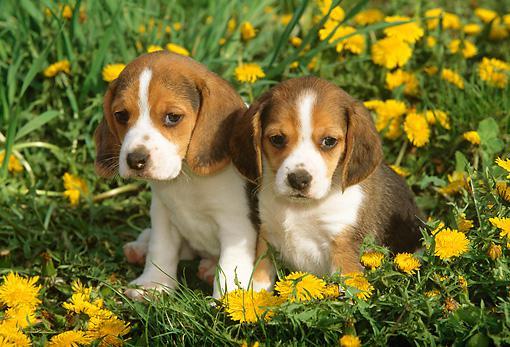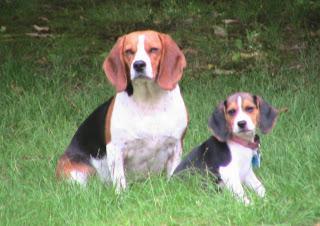The first image is the image on the left, the second image is the image on the right. Given the left and right images, does the statement "Two camera-facing beagles of similar size and coloring sit upright in the grass, and neither are young puppies." hold true? Answer yes or no. No. The first image is the image on the left, the second image is the image on the right. For the images displayed, is the sentence "There are exactly four dogs, and at least two of them seem to be puppies." factually correct? Answer yes or no. Yes. 